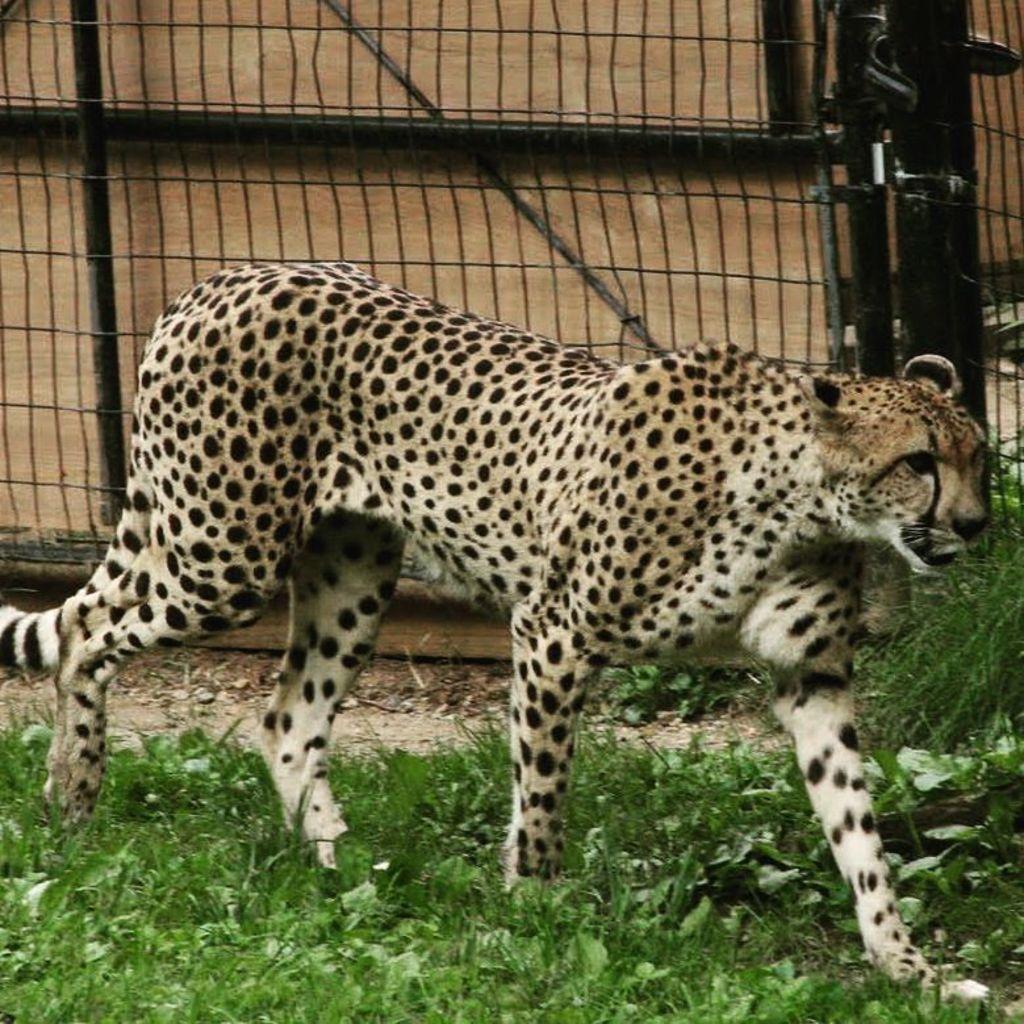Can you describe this image briefly? In this image there is a Cheetah, there is grass towards the bottom of the image, there are plants towards the right of the image, at the background of the image there is a fencing. 